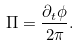Convert formula to latex. <formula><loc_0><loc_0><loc_500><loc_500>\Pi = \frac { \partial _ { t } \phi } { 2 \pi } .</formula> 